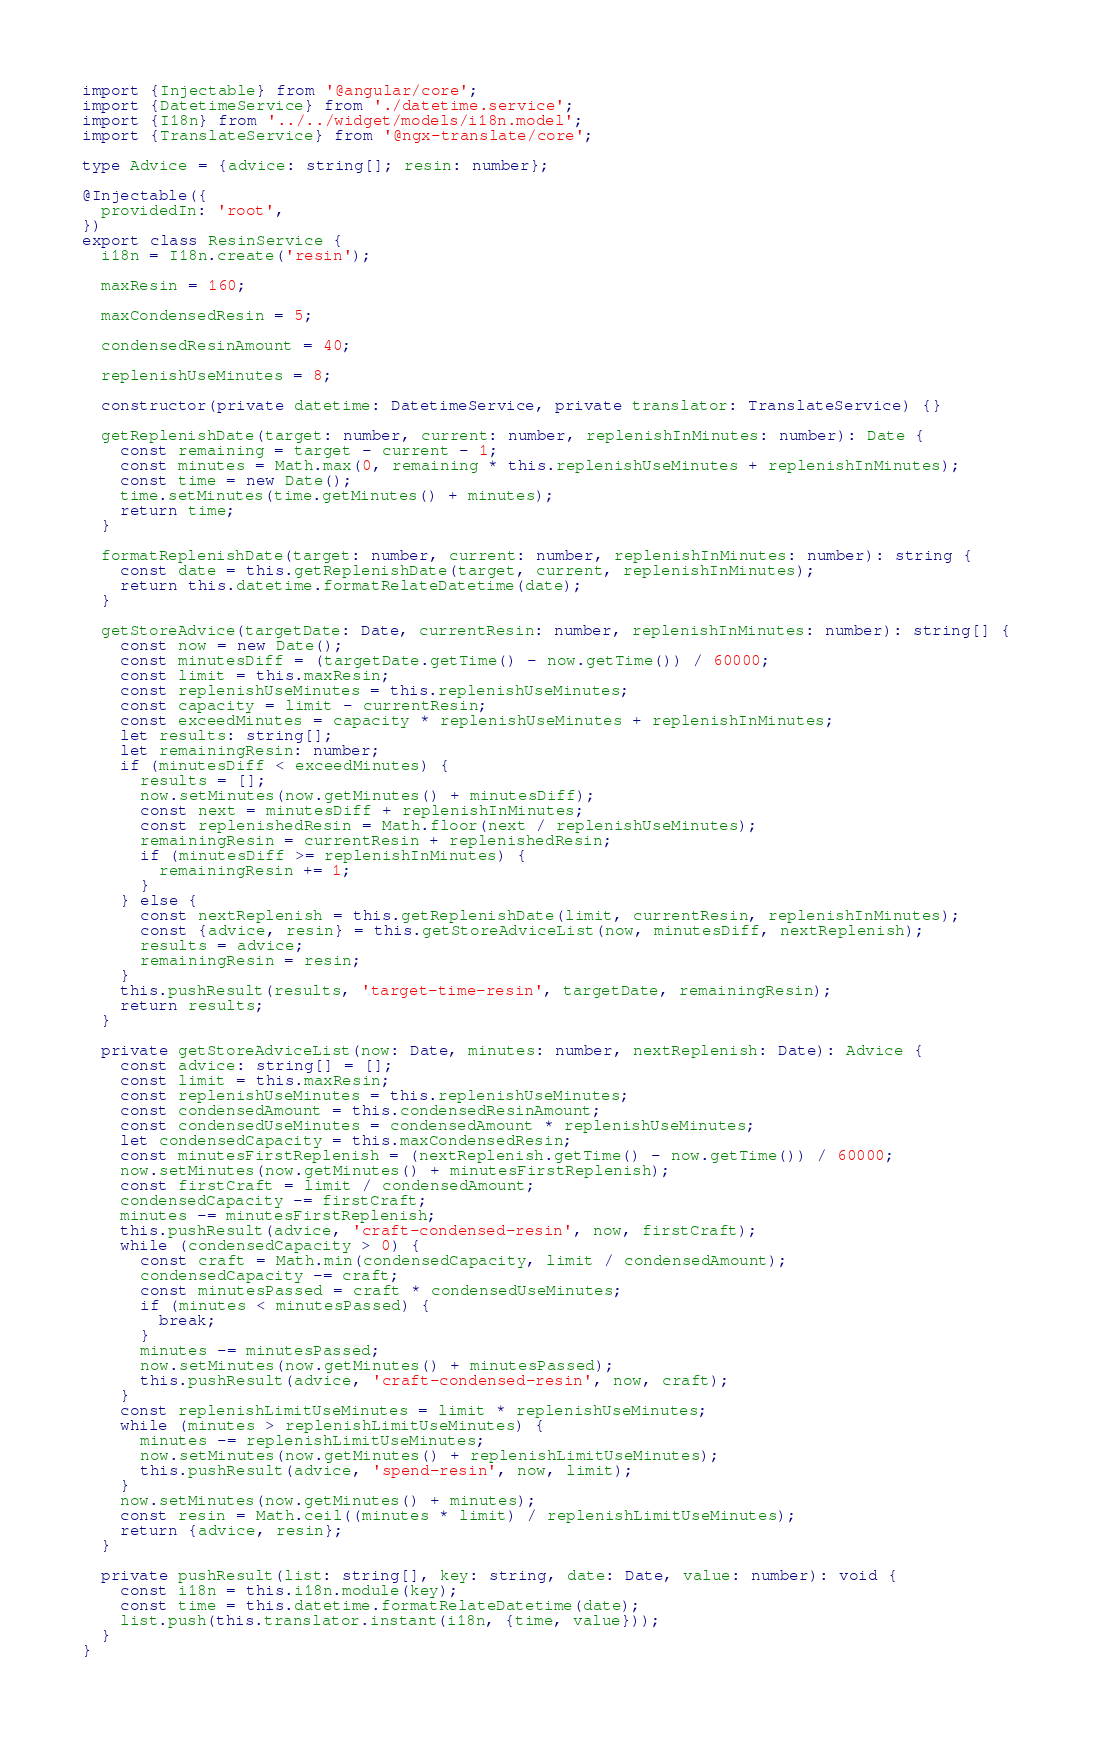<code> <loc_0><loc_0><loc_500><loc_500><_TypeScript_>import {Injectable} from '@angular/core';
import {DatetimeService} from './datetime.service';
import {I18n} from '../../widget/models/i18n.model';
import {TranslateService} from '@ngx-translate/core';

type Advice = {advice: string[]; resin: number};

@Injectable({
  providedIn: 'root',
})
export class ResinService {
  i18n = I18n.create('resin');

  maxResin = 160;

  maxCondensedResin = 5;

  condensedResinAmount = 40;

  replenishUseMinutes = 8;

  constructor(private datetime: DatetimeService, private translator: TranslateService) {}

  getReplenishDate(target: number, current: number, replenishInMinutes: number): Date {
    const remaining = target - current - 1;
    const minutes = Math.max(0, remaining * this.replenishUseMinutes + replenishInMinutes);
    const time = new Date();
    time.setMinutes(time.getMinutes() + minutes);
    return time;
  }

  formatReplenishDate(target: number, current: number, replenishInMinutes: number): string {
    const date = this.getReplenishDate(target, current, replenishInMinutes);
    return this.datetime.formatRelateDatetime(date);
  }

  getStoreAdvice(targetDate: Date, currentResin: number, replenishInMinutes: number): string[] {
    const now = new Date();
    const minutesDiff = (targetDate.getTime() - now.getTime()) / 60000;
    const limit = this.maxResin;
    const replenishUseMinutes = this.replenishUseMinutes;
    const capacity = limit - currentResin;
    const exceedMinutes = capacity * replenishUseMinutes + replenishInMinutes;
    let results: string[];
    let remainingResin: number;
    if (minutesDiff < exceedMinutes) {
      results = [];
      now.setMinutes(now.getMinutes() + minutesDiff);
      const next = minutesDiff + replenishInMinutes;
      const replenishedResin = Math.floor(next / replenishUseMinutes);
      remainingResin = currentResin + replenishedResin;
      if (minutesDiff >= replenishInMinutes) {
        remainingResin += 1;
      }
    } else {
      const nextReplenish = this.getReplenishDate(limit, currentResin, replenishInMinutes);
      const {advice, resin} = this.getStoreAdviceList(now, minutesDiff, nextReplenish);
      results = advice;
      remainingResin = resin;
    }
    this.pushResult(results, 'target-time-resin', targetDate, remainingResin);
    return results;
  }

  private getStoreAdviceList(now: Date, minutes: number, nextReplenish: Date): Advice {
    const advice: string[] = [];
    const limit = this.maxResin;
    const replenishUseMinutes = this.replenishUseMinutes;
    const condensedAmount = this.condensedResinAmount;
    const condensedUseMinutes = condensedAmount * replenishUseMinutes;
    let condensedCapacity = this.maxCondensedResin;
    const minutesFirstReplenish = (nextReplenish.getTime() - now.getTime()) / 60000;
    now.setMinutes(now.getMinutes() + minutesFirstReplenish);
    const firstCraft = limit / condensedAmount;
    condensedCapacity -= firstCraft;
    minutes -= minutesFirstReplenish;
    this.pushResult(advice, 'craft-condensed-resin', now, firstCraft);
    while (condensedCapacity > 0) {
      const craft = Math.min(condensedCapacity, limit / condensedAmount);
      condensedCapacity -= craft;
      const minutesPassed = craft * condensedUseMinutes;
      if (minutes < minutesPassed) {
        break;
      }
      minutes -= minutesPassed;
      now.setMinutes(now.getMinutes() + minutesPassed);
      this.pushResult(advice, 'craft-condensed-resin', now, craft);
    }
    const replenishLimitUseMinutes = limit * replenishUseMinutes;
    while (minutes > replenishLimitUseMinutes) {
      minutes -= replenishLimitUseMinutes;
      now.setMinutes(now.getMinutes() + replenishLimitUseMinutes);
      this.pushResult(advice, 'spend-resin', now, limit);
    }
    now.setMinutes(now.getMinutes() + minutes);
    const resin = Math.ceil((minutes * limit) / replenishLimitUseMinutes);
    return {advice, resin};
  }

  private pushResult(list: string[], key: string, date: Date, value: number): void {
    const i18n = this.i18n.module(key);
    const time = this.datetime.formatRelateDatetime(date);
    list.push(this.translator.instant(i18n, {time, value}));
  }
}
</code> 